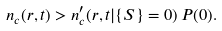Convert formula to latex. <formula><loc_0><loc_0><loc_500><loc_500>n _ { c } ( { r } , t ) > n ^ { \prime } _ { c } ( { r } , t | \{ S \} = 0 ) \, P ( 0 ) .</formula> 